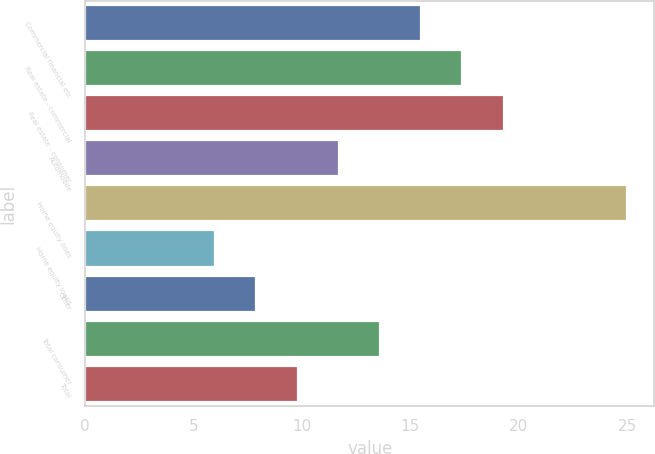<chart> <loc_0><loc_0><loc_500><loc_500><bar_chart><fcel>Commercial financial etc<fcel>Real estate - commercial<fcel>Real estate - consumer<fcel>Automobile<fcel>Home equity lines<fcel>Home equity loans<fcel>Other<fcel>Total consumer<fcel>Total<nl><fcel>15.5<fcel>17.4<fcel>19.3<fcel>11.7<fcel>25<fcel>6<fcel>7.9<fcel>13.6<fcel>9.8<nl></chart> 